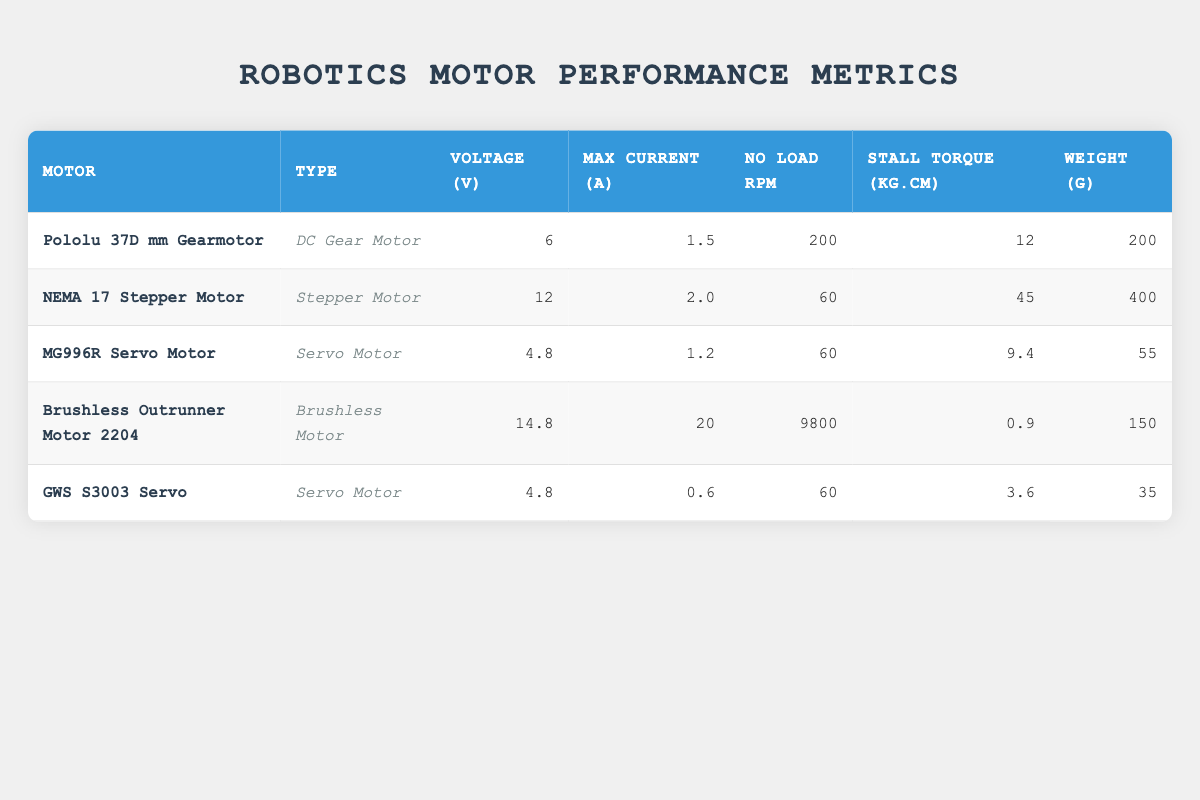What is the maximum current of the Brushless Outrunner Motor 2204? The maximum current is explicitly listed in the table under the "Max Current (A)" column for the Brushless Outrunner Motor 2204, which shows a value of 20 A.
Answer: 20 A What type of motor has the highest stall torque? To find the highest stall torque, I compare the values in the "Stall Torque (kg.cm)" column for all motors. The NEMA 17 Stepper Motor has the highest value of 45 kg.cm.
Answer: NEMA 17 Stepper Motor What is the total weight of the MG996R Servo Motor and GWS S3003 Servo? I sum the weights of the MG996R Servo Motor and GWS S3003 Servo listed in the "Weight (g)" column: 55 g (MG996R) + 35 g (GWS S3003) = 90 g.
Answer: 90 g Is the No Load RPM of the NEMA 17 Stepper Motor greater than the Pololu 37D mm Gearmotor? I check the "No Load RPM" values for both motors: NEMA 17 Stepper Motor has 60 RPM and Pololu 37D Gearmotor has 200 RPM. Since 60 is not greater than 200, the answer is no.
Answer: No What is the average voltage of the Servo Motors in the table? I identify the servo motors: MG996R and GWS S3003. Their voltages are 4.8 V. I calculate the average: (4.8 + 4.8) / 2 = 4.8 V.
Answer: 4.8 V 